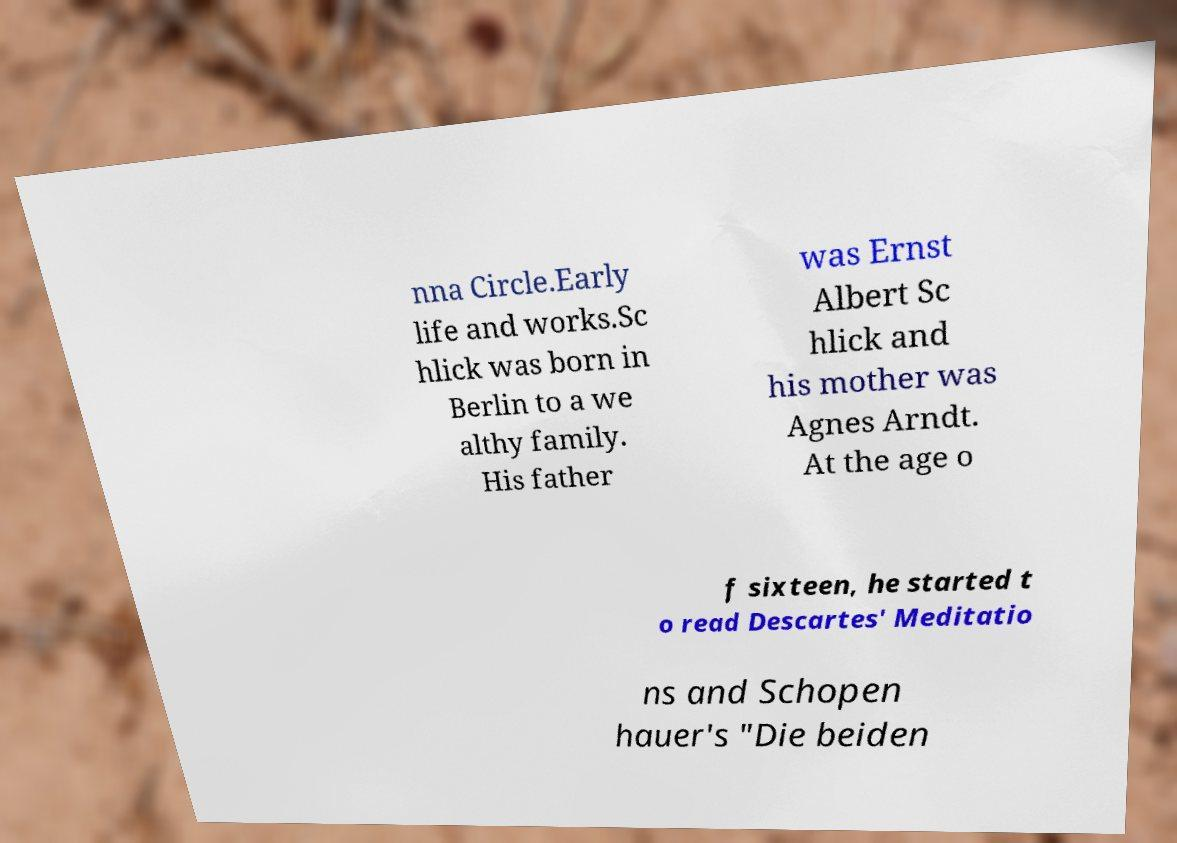There's text embedded in this image that I need extracted. Can you transcribe it verbatim? nna Circle.Early life and works.Sc hlick was born in Berlin to a we althy family. His father was Ernst Albert Sc hlick and his mother was Agnes Arndt. At the age o f sixteen, he started t o read Descartes' Meditatio ns and Schopen hauer's "Die beiden 